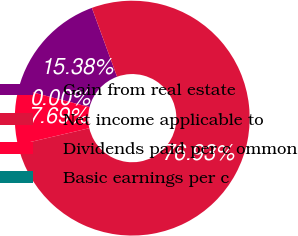Convert chart. <chart><loc_0><loc_0><loc_500><loc_500><pie_chart><fcel>Gain from real estate<fcel>Net income applicable to<fcel>Dividends paid per c ommon<fcel>Basic earnings per c<nl><fcel>15.38%<fcel>76.92%<fcel>7.69%<fcel>0.0%<nl></chart> 